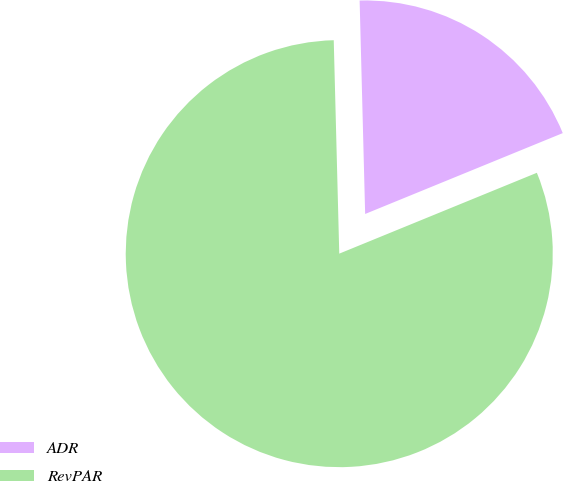<chart> <loc_0><loc_0><loc_500><loc_500><pie_chart><fcel>ADR<fcel>RevPAR<nl><fcel>19.23%<fcel>80.77%<nl></chart> 